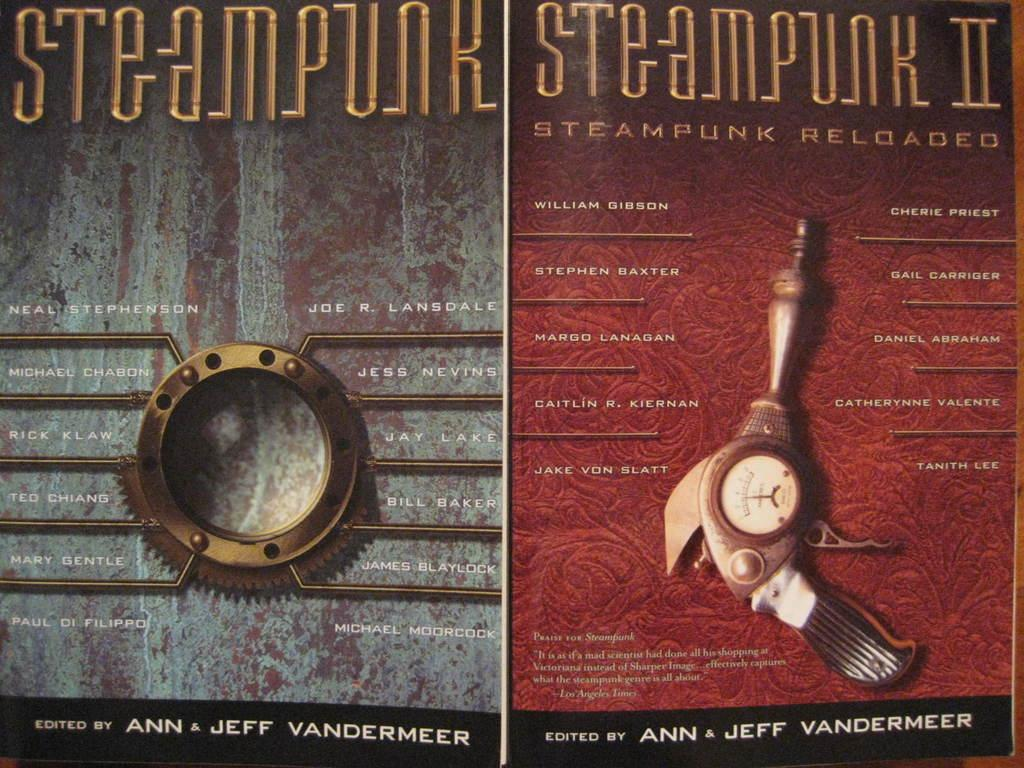What is present on the posters in the image? There are posters in the image, and they contain text and images of some objects. Can you describe the content of the posters? The posters contain text and images of some objects. What type of texture can be felt on the edge of the posters in the image? There is no information provided about the texture of the posters or their edges, so it cannot be determined from the image. 